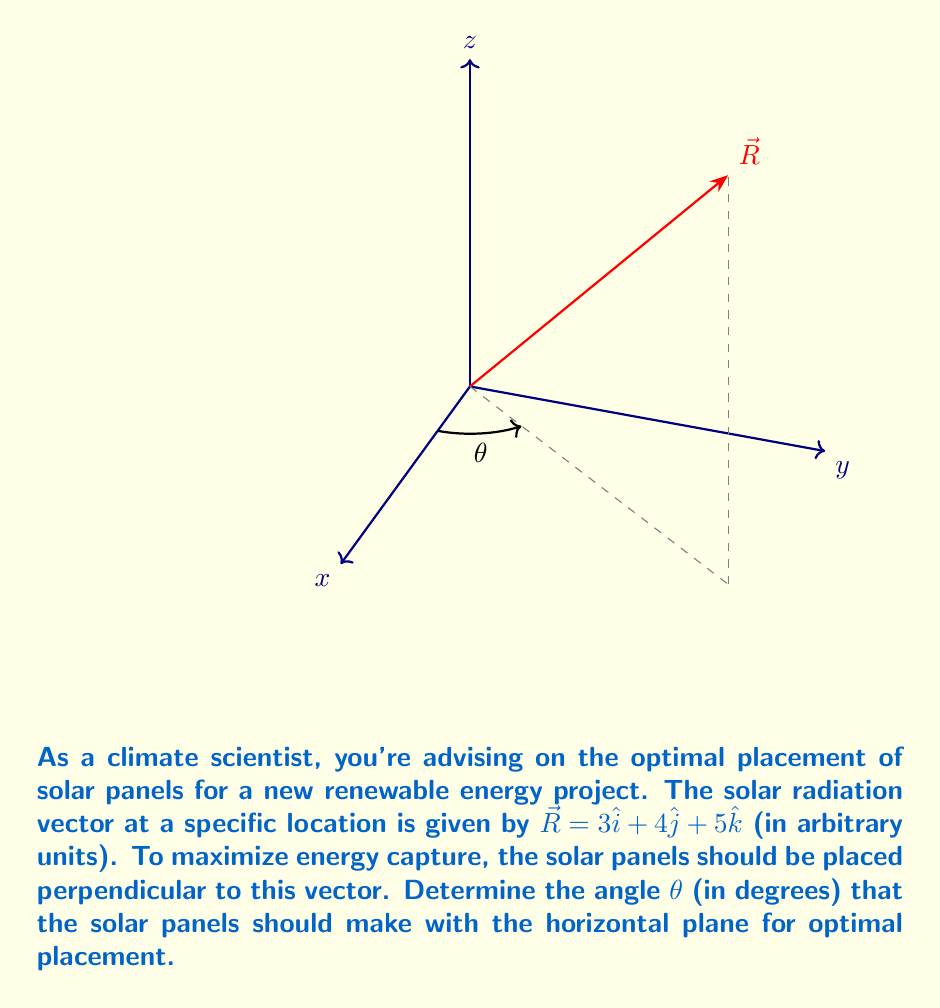Solve this math problem. Let's approach this step-by-step:

1) The solar radiation vector is given as $\vec{R} = 3\hat{i} + 4\hat{j} + 5\hat{k}$.

2) To find the angle with the horizontal plane, we need to calculate the angle between $\vec{R}$ and its projection on the xy-plane.

3) The projection of $\vec{R}$ on the xy-plane is $\vec{R}_{xy} = 3\hat{i} + 4\hat{j}$.

4) We can use the dot product formula to find the angle:

   $$\cos \theta = \frac{\vec{R} \cdot \vec{R}_{xy}}{|\vec{R}||\vec{R}_{xy}|}$$

5) Calculate the magnitudes:
   $$|\vec{R}| = \sqrt{3^2 + 4^2 + 5^2} = \sqrt{50}$$
   $$|\vec{R}_{xy}| = \sqrt{3^2 + 4^2} = 5$$

6) Calculate the dot product:
   $$\vec{R} \cdot \vec{R}_{xy} = 3(3) + 4(4) + 5(0) = 25$$

7) Substitute into the formula:
   $$\cos \theta = \frac{25}{\sqrt{50} \cdot 5} = \frac{25}{5\sqrt{50}} = \frac{5}{\sqrt{50}}$$

8) Take the inverse cosine (arccos) of both sides:
   $$\theta = \arccos(\frac{5}{\sqrt{50}})$$

9) Convert to degrees:
   $$\theta = \arccos(\frac{5}{\sqrt{50}}) \cdot \frac{180°}{\pi} \approx 44.4°$$

10) The optimal angle for the solar panels is 90° - θ, as they should be perpendicular to $\vec{R}$:
    $$90° - 44.4° \approx 45.6°$$
Answer: $45.6°$ 